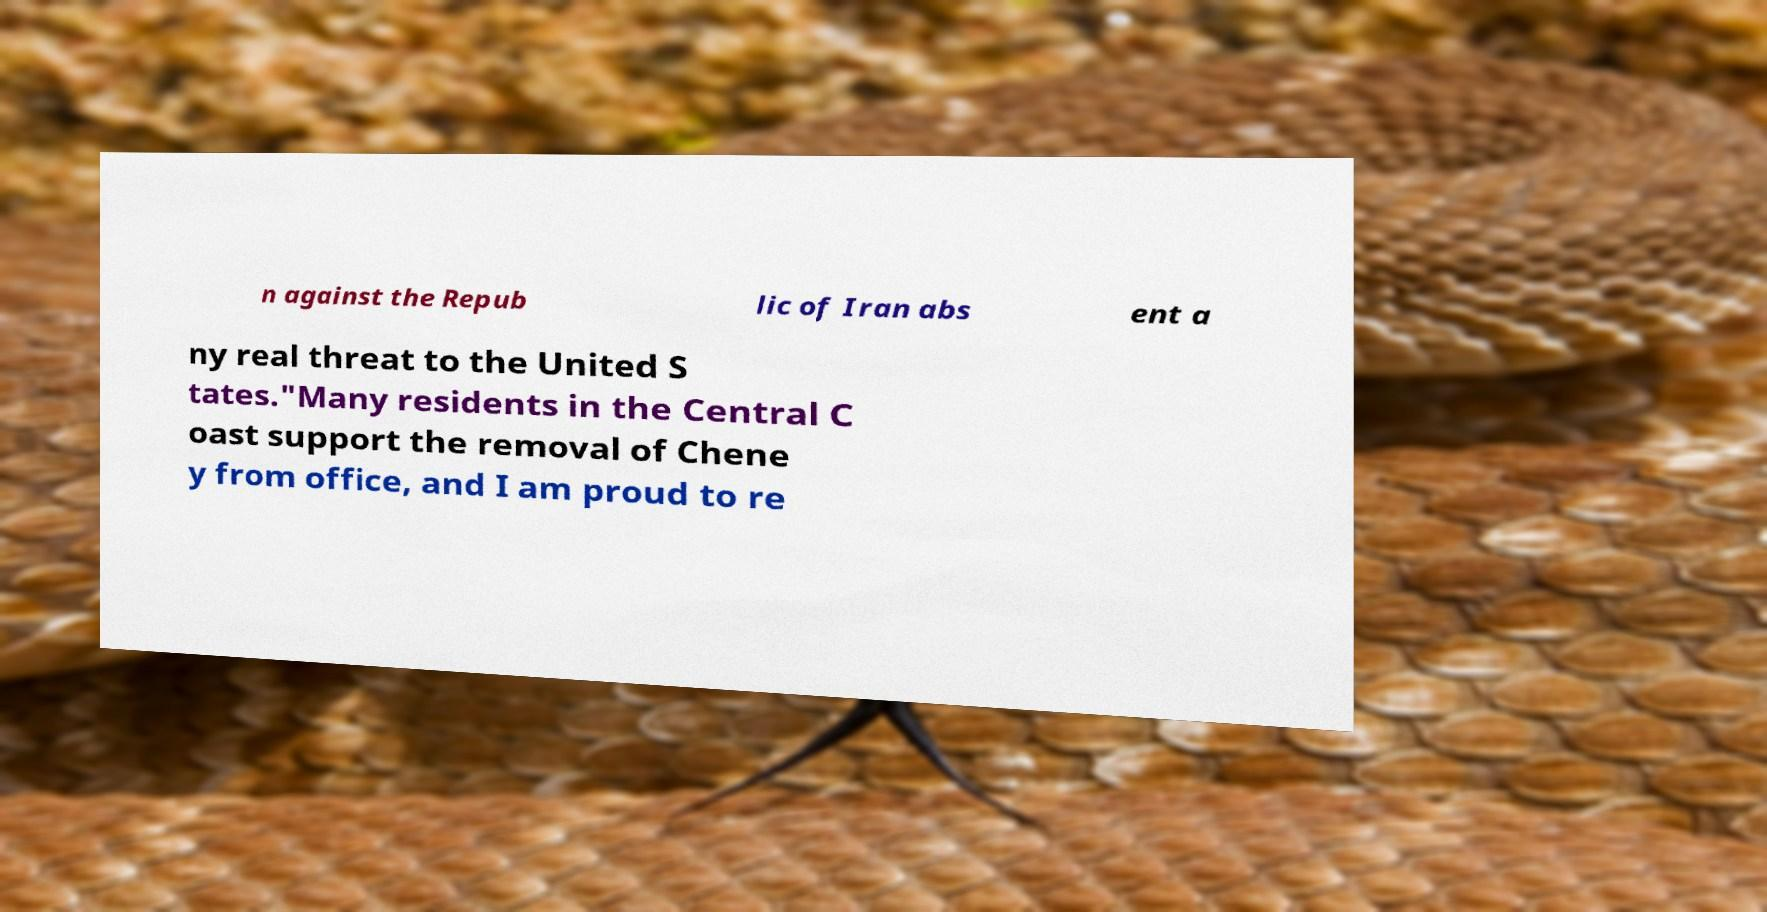Can you accurately transcribe the text from the provided image for me? n against the Repub lic of Iran abs ent a ny real threat to the United S tates."Many residents in the Central C oast support the removal of Chene y from office, and I am proud to re 